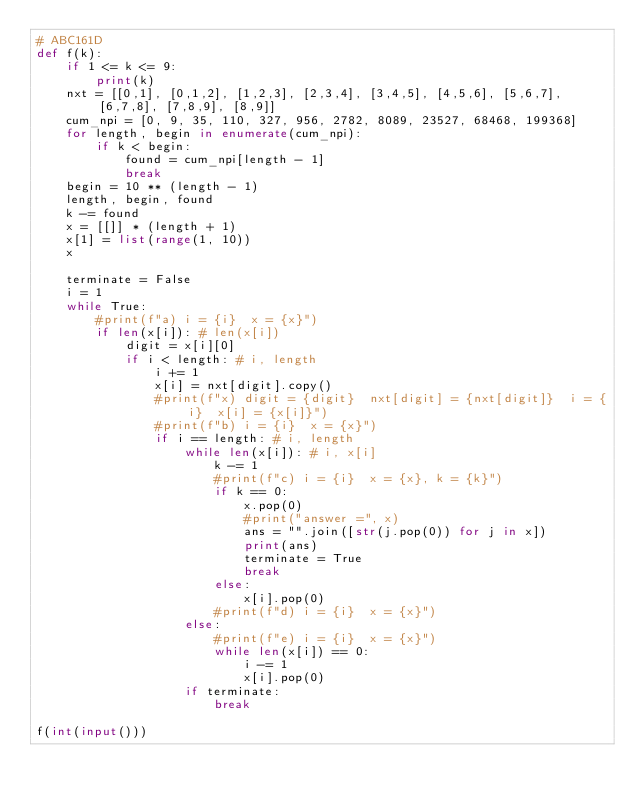Convert code to text. <code><loc_0><loc_0><loc_500><loc_500><_Python_># ABC161D
def f(k):
    if 1 <= k <= 9:
        print(k)
    nxt = [[0,1], [0,1,2], [1,2,3], [2,3,4], [3,4,5], [4,5,6], [5,6,7], [6,7,8], [7,8,9], [8,9]]
    cum_npi = [0, 9, 35, 110, 327, 956, 2782, 8089, 23527, 68468, 199368]
    for length, begin in enumerate(cum_npi):
        if k < begin:
            found = cum_npi[length - 1]
            break
    begin = 10 ** (length - 1)
    length, begin, found
    k -= found
    x = [[]] * (length + 1)
    x[1] = list(range(1, 10))
    x

    terminate = False
    i = 1
    while True:
        #print(f"a) i = {i}  x = {x}")
        if len(x[i]): # len(x[i])
            digit = x[i][0]
            if i < length: # i, length
                i += 1
                x[i] = nxt[digit].copy()
                #print(f"x) digit = {digit}  nxt[digit] = {nxt[digit]}  i = {i}  x[i] = {x[i]}")
                #print(f"b) i = {i}  x = {x}")
                if i == length: # i, length
                    while len(x[i]): # i, x[i]
                        k -= 1
                        #print(f"c) i = {i}  x = {x}, k = {k}")
                        if k == 0:
                            x.pop(0)
                            #print("answer =", x)
                            ans = "".join([str(j.pop(0)) for j in x])
                            print(ans)
                            terminate = True
                            break
                        else:
                            x[i].pop(0)
                        #print(f"d) i = {i}  x = {x}")
                    else:
                        #print(f"e) i = {i}  x = {x}")
                        while len(x[i]) == 0:
                            i -= 1
                            x[i].pop(0)
                    if terminate:
                        break

f(int(input()))
</code> 